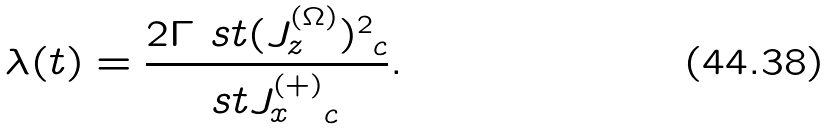<formula> <loc_0><loc_0><loc_500><loc_500>\lambda ( t ) = \frac { 2 \Gamma \ s t { ( J _ { z } ^ { ( \Omega ) } ) ^ { 2 } } _ { c } } { \ s t { J _ { x } ^ { ( + ) } } _ { c } } .</formula> 